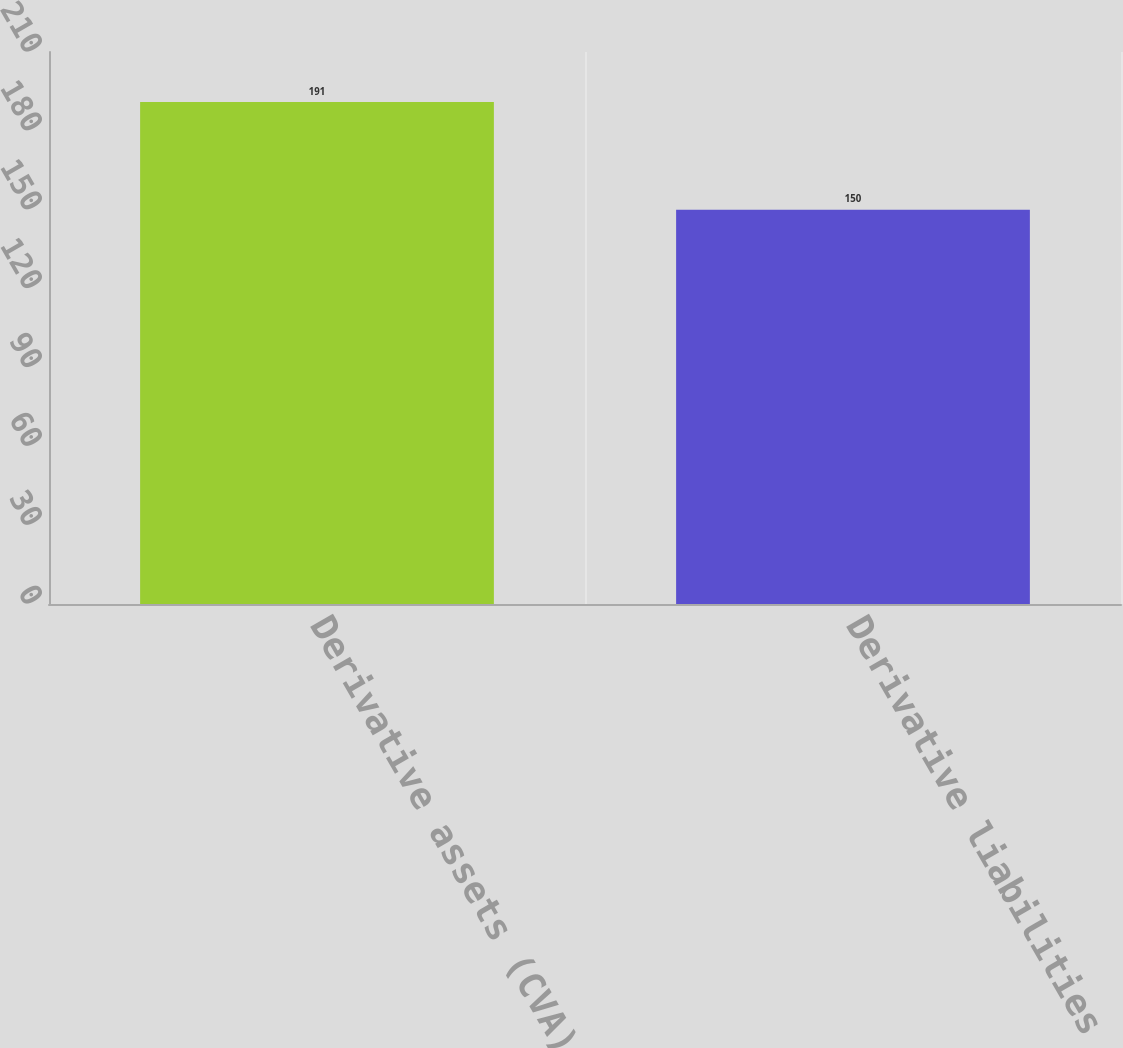<chart> <loc_0><loc_0><loc_500><loc_500><bar_chart><fcel>Derivative assets (CVA) (1)<fcel>Derivative liabilities (DVA)<nl><fcel>191<fcel>150<nl></chart> 